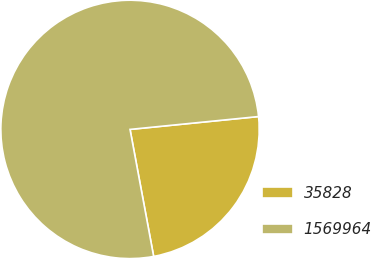<chart> <loc_0><loc_0><loc_500><loc_500><pie_chart><fcel>35828<fcel>1569964<nl><fcel>23.66%<fcel>76.34%<nl></chart> 